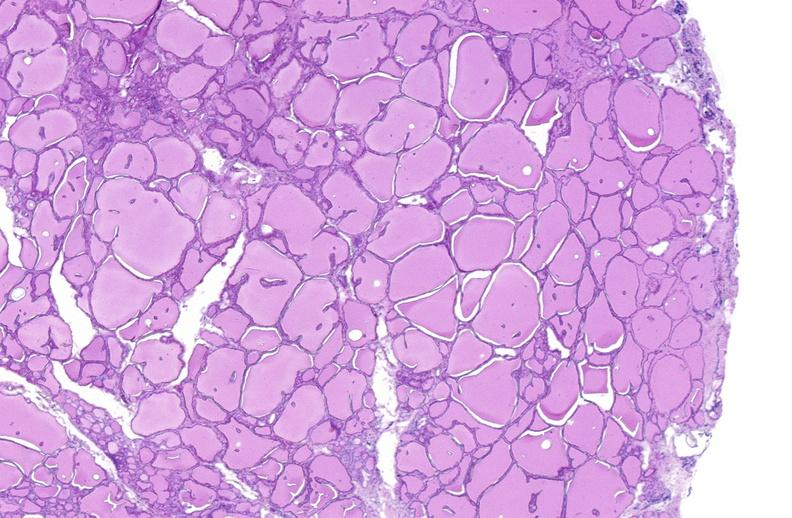s endocrine present?
Answer the question using a single word or phrase. Yes 